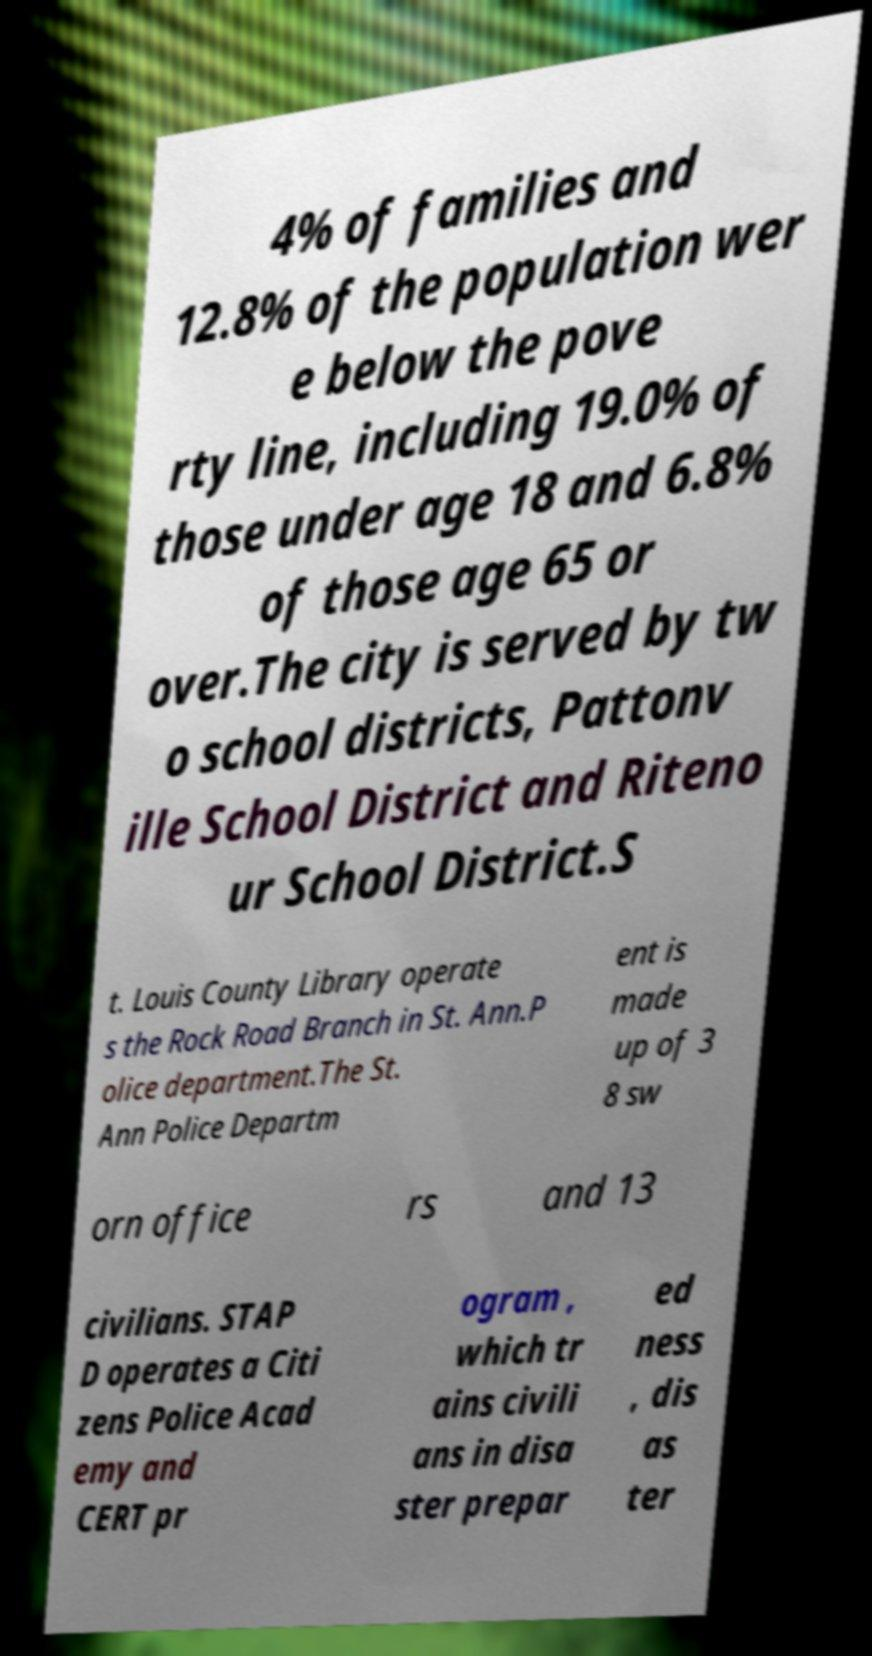There's text embedded in this image that I need extracted. Can you transcribe it verbatim? 4% of families and 12.8% of the population wer e below the pove rty line, including 19.0% of those under age 18 and 6.8% of those age 65 or over.The city is served by tw o school districts, Pattonv ille School District and Riteno ur School District.S t. Louis County Library operate s the Rock Road Branch in St. Ann.P olice department.The St. Ann Police Departm ent is made up of 3 8 sw orn office rs and 13 civilians. STAP D operates a Citi zens Police Acad emy and CERT pr ogram , which tr ains civili ans in disa ster prepar ed ness , dis as ter 